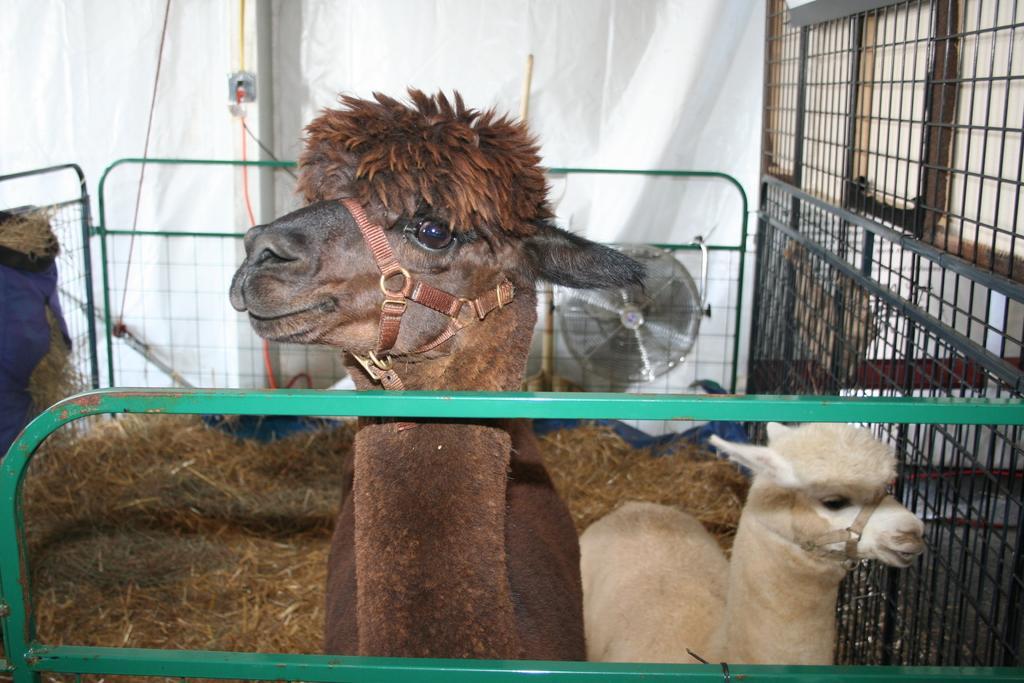Can you describe this image briefly? In this image I can see two llamas which are of brown colour and white colour. I can also see iron gate, yellow grass and a fan in background. 